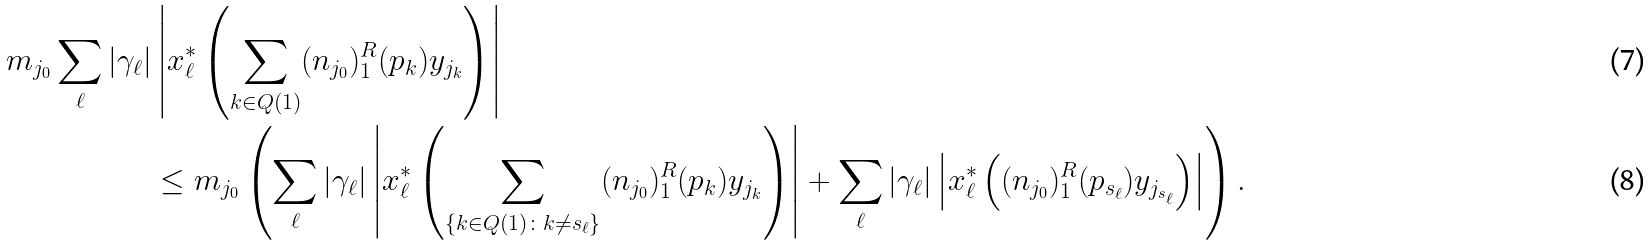<formula> <loc_0><loc_0><loc_500><loc_500>m _ { j _ { 0 } } \sum _ { \ell } | \gamma _ { \ell } | & \left | x ^ { * } _ { \ell } \left ( \sum _ { k \in Q ( 1 ) } ( n _ { j _ { 0 } } ) _ { 1 } ^ { R } ( p _ { k } ) y _ { j _ { k } } \right ) \right | \\ & \leq m _ { j _ { 0 } } \left ( \sum _ { \ell } | \gamma _ { \ell } | \left | x ^ { * } _ { \ell } \left ( \sum _ { \{ k \in Q ( 1 ) \colon k \not = s _ { \ell } \} } ( n _ { j _ { 0 } } ) _ { 1 } ^ { R } ( p _ { k } ) y _ { j _ { k } } \right ) \right | + \sum _ { \ell } | \gamma _ { \ell } | \left | x ^ { * } _ { \ell } \left ( ( n _ { j _ { 0 } } ) _ { 1 } ^ { R } ( p _ { s _ { \ell } } ) y _ { j _ { s _ { \ell } } } \right ) \right | \right ) .</formula> 